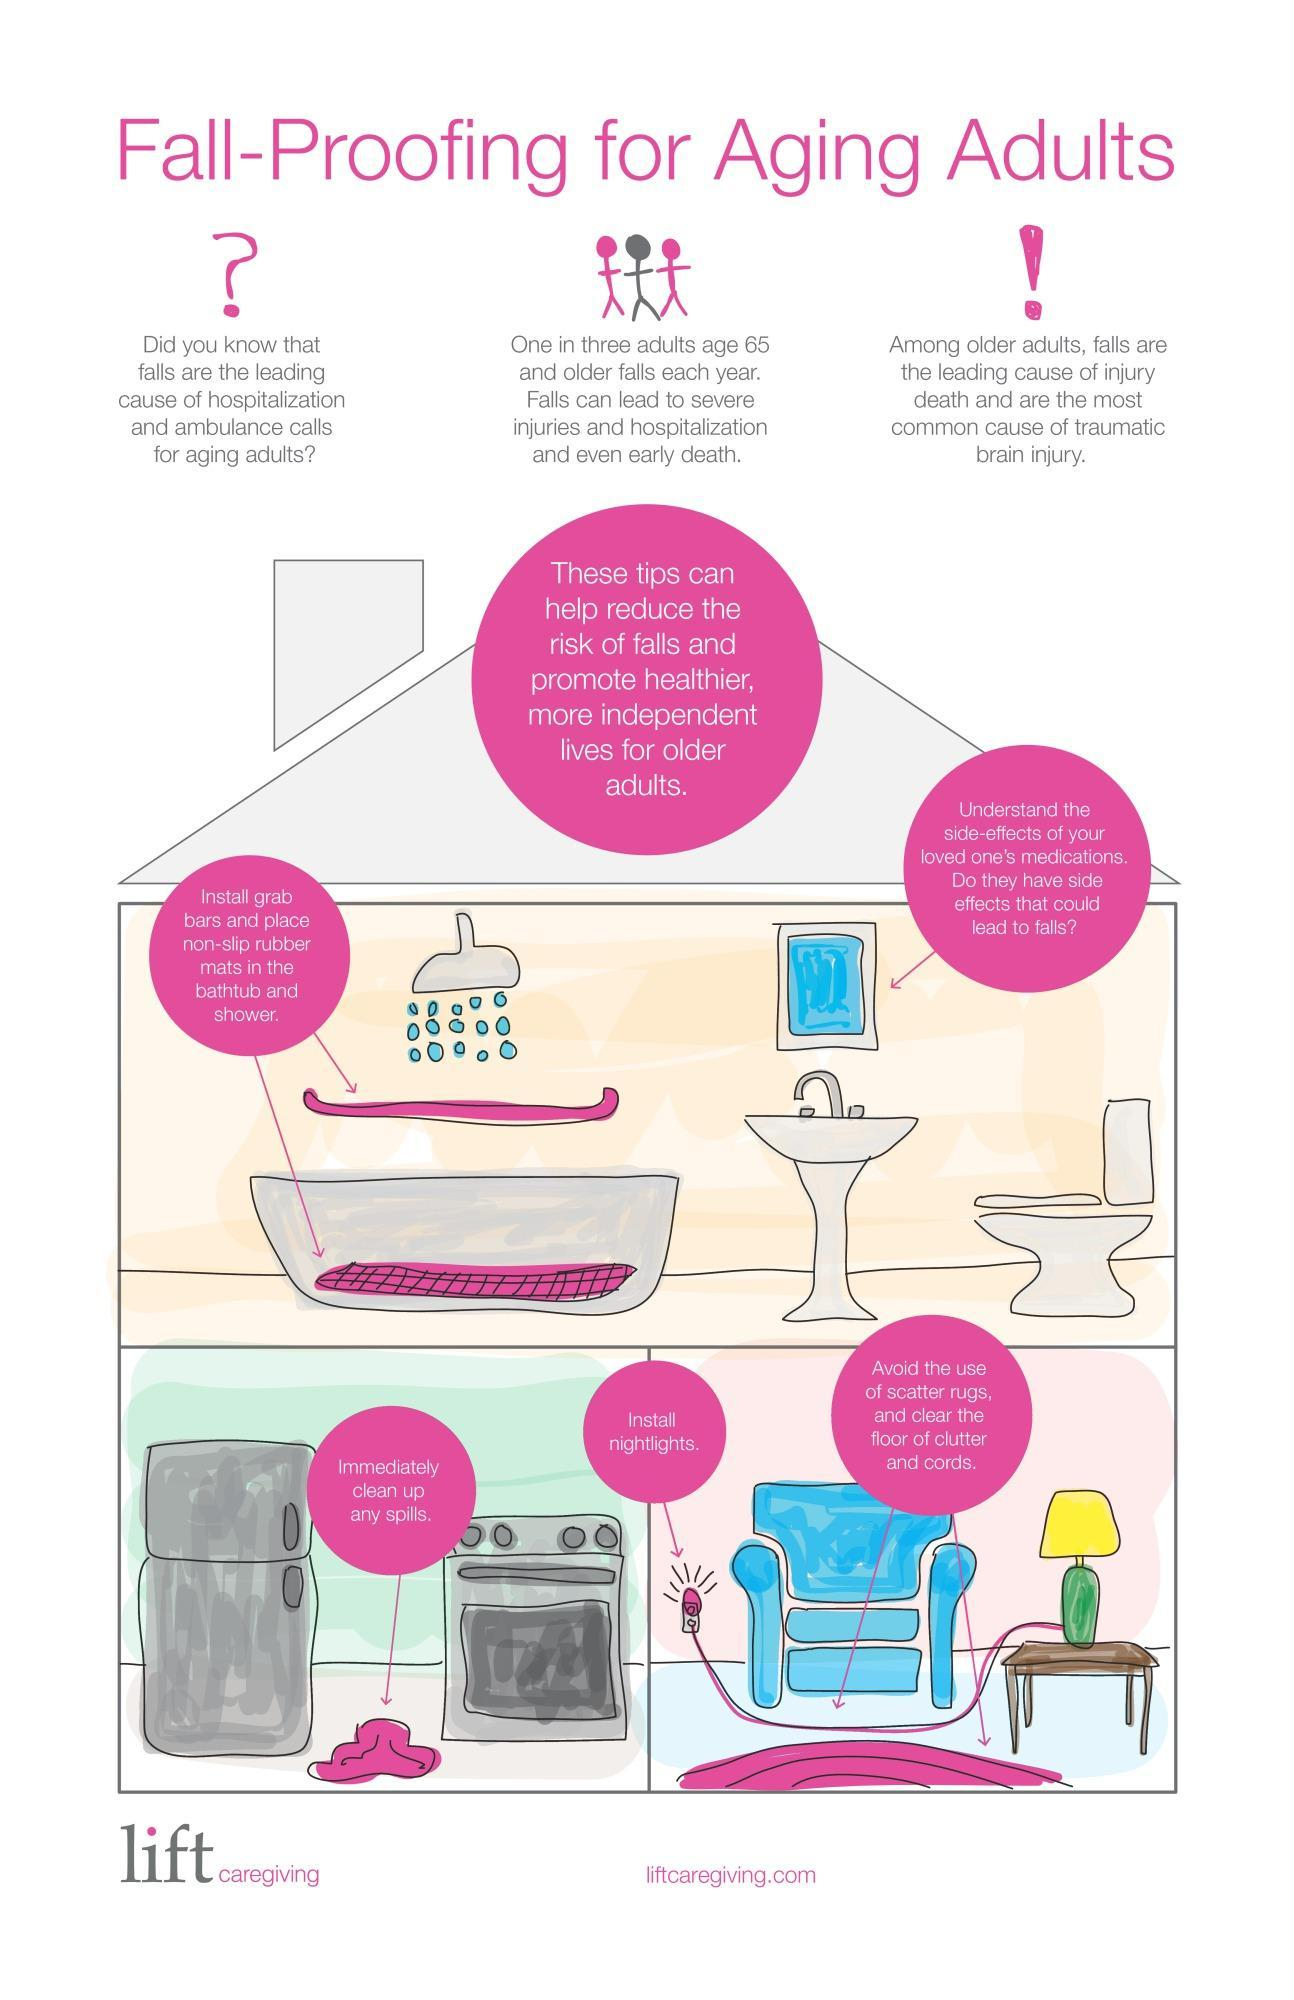How many tips are mentioned to reduce the risk of falls
Answer the question with a short phrase. 5 Falls are common among people of which of the category infants, senior citizen, middle aged? senior citizen What are the harmful effects of Falls? Severe Injuries and hospitalization and even early death 